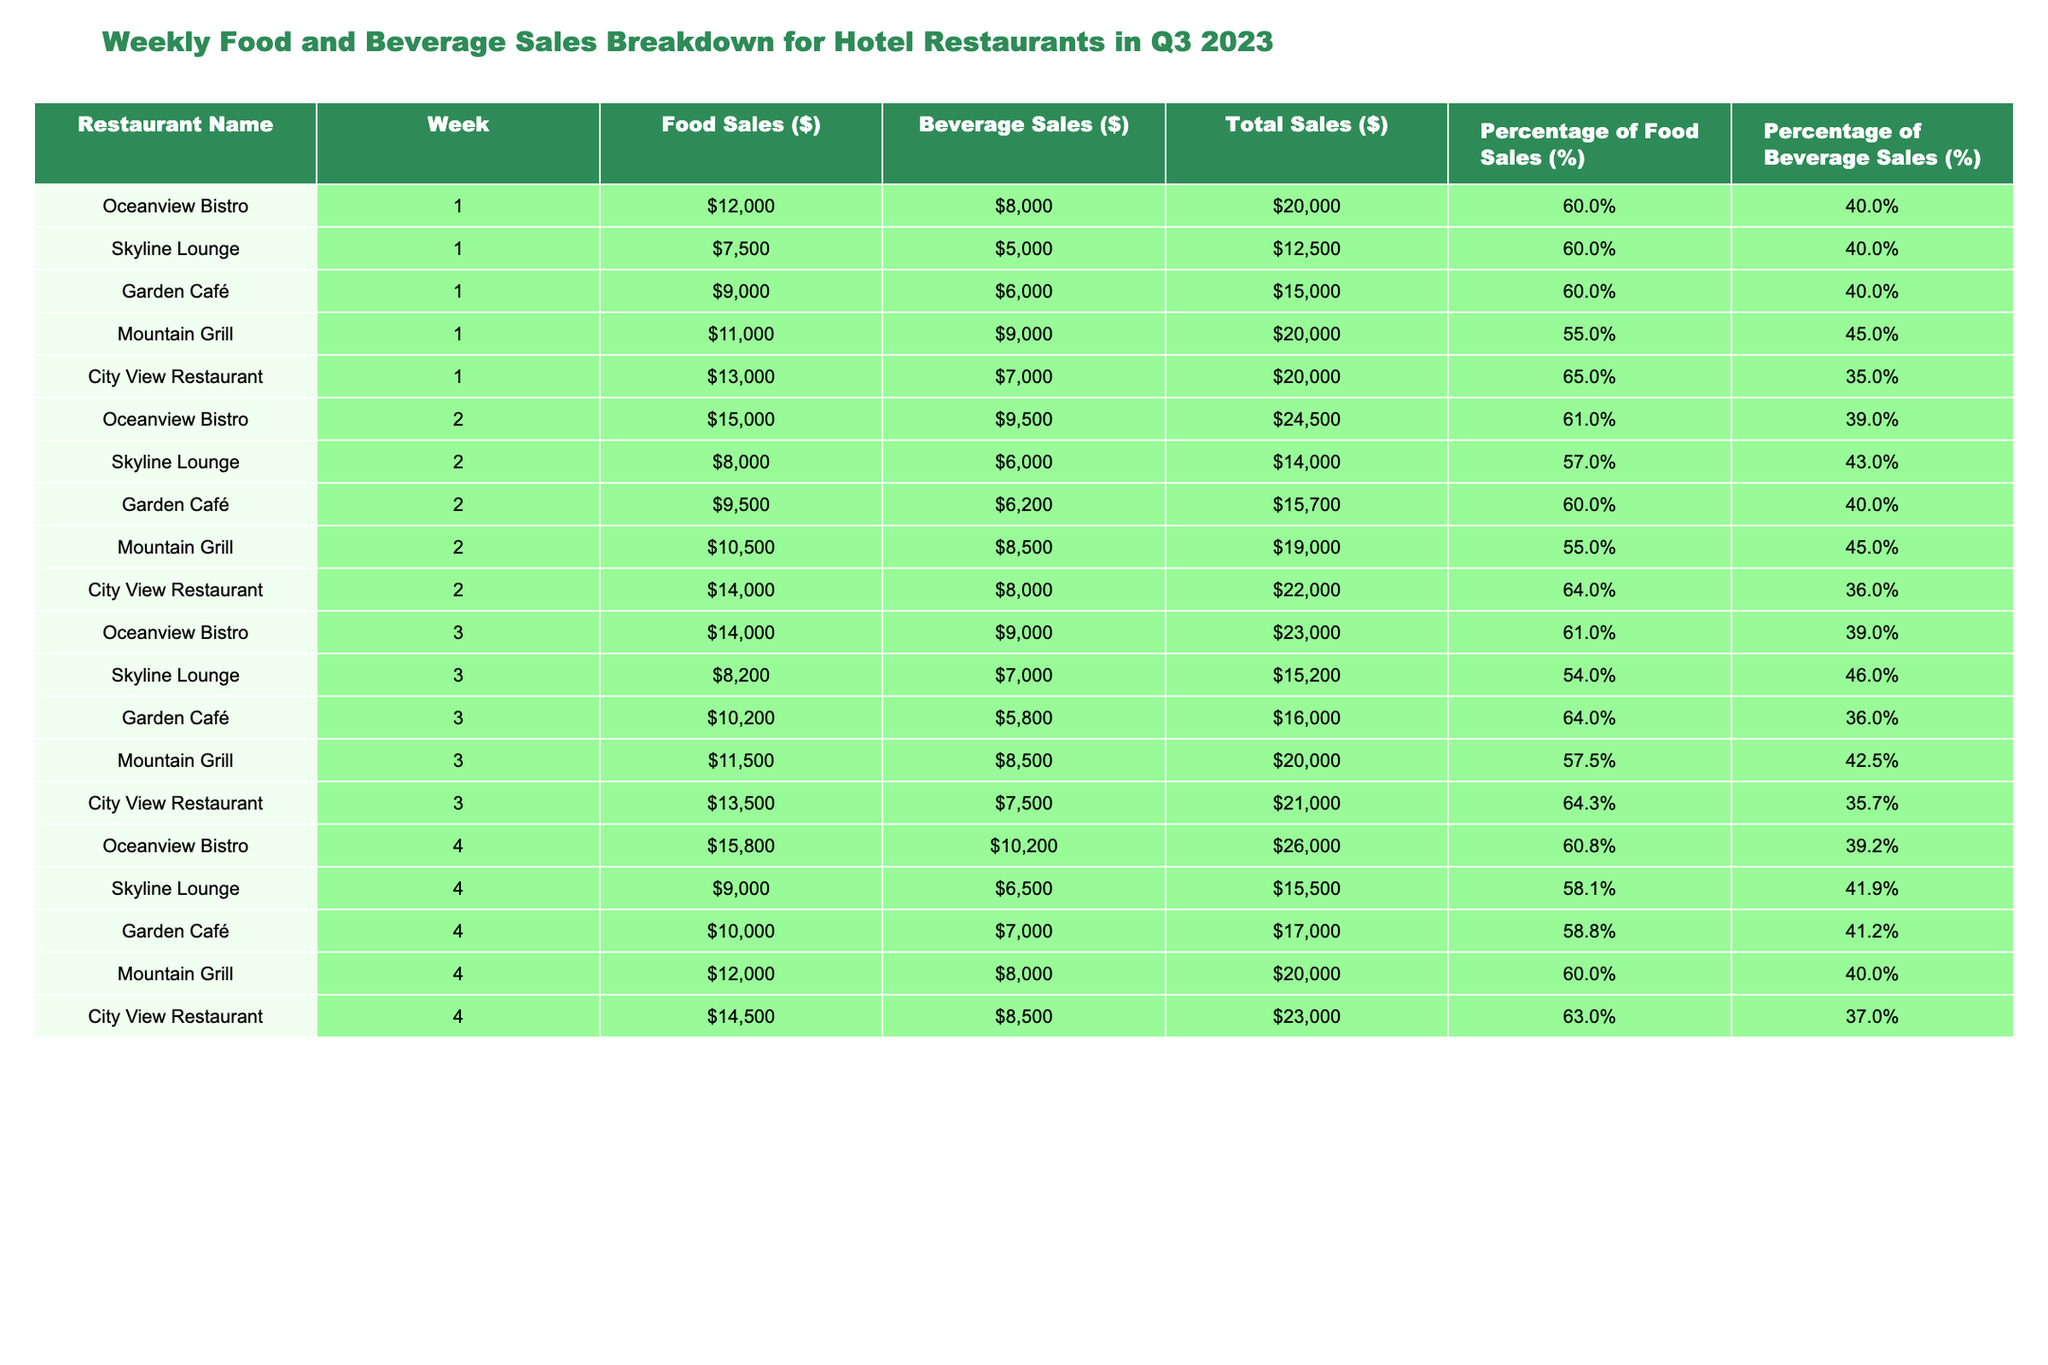What's the total food sales for Oceanview Bistro in week 4? The food sales for Oceanview Bistro in week 4 is $15,800, which is directly stated in the table.
Answer: $15,800 Which restaurant had the highest percentage of beverage sales in week 3? In week 3, Skyline Lounge had 46% beverage sales, which is the highest percentage among all the restaurants listed for that week.
Answer: Skyline Lounge What is the average total sales for City View Restaurant across all weeks? The total sales for City View Restaurant across the four weeks are $20,000 (Week 1) + $22,000 (Week 2) + $21,000 (Week 3) + $23,000 (Week 4) = $86,000. There are 4 weeks, so the average is $86,000 / 4 = $21,500.
Answer: $21,500 Did Garden Café have a higher food sale than Mountain Grill in week 2? In week 2, Garden Café had $9,500 in food sales, while Mountain Grill had $10,500, so Mountain Grill had higher sales.
Answer: No What were the total food and beverage sales for Skyline Lounge across all weeks? The total food sales for Skyline Lounge are $7,500 (Week 1) + $8,000 (Week 2) + $8,200 (Week 3) + $9,000 (Week 4) = $32,700. The total beverage sales are $5,000 (Week 1) + $6,000 (Week 2) + $7,000 (Week 3) + $6,500 (Week 4) = $24,500. Therefore, the combined total is $32,700 + $24,500 = $57,200.
Answer: $57,200 Which restaurant consistently achieved a food sales percentage above 60% in week 3? In week 3, City View Restaurant achieved a food sales percentage of 64.3%, which is above 60%, while all other restaurants had percentages below that number.
Answer: City View Restaurant What is the difference in total sales between Oceanview Bistro in week 2 and Mountain Grill in week 4? The total sales for Oceanview Bistro in week 2 is $24,500, and for Mountain Grill in week 4, it's $20,000. The difference is $24,500 - $20,000 = $4,500.
Answer: $4,500 Which restaurant had the lowest total sales in week 1? The Skyline Lounge had the lowest total sales of $12,500 in week 1, compared to the other restaurants which had higher sales.
Answer: Skyline Lounge What is the combined percentage of food sales for Garden Café and Mountain Grill in week 4? Garden Café had a food sales percentage of 58.8% and Mountain Grill had 60%. The combined percentage is 58.8% + 60% = 118.8%.
Answer: 118.8% 